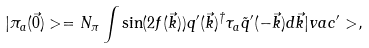Convert formula to latex. <formula><loc_0><loc_0><loc_500><loc_500>| \pi _ { a } ( \vec { 0 } ) > = N _ { \pi } \int \sin ( 2 f ( \vec { k } ) ) q ^ { \prime } ( \vec { k } ) ^ { \dagger } \tau _ { a } \tilde { q } ^ { \prime } ( - \vec { k } ) d \vec { k } | v a c ^ { \prime } > ,</formula> 